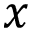<formula> <loc_0><loc_0><loc_500><loc_500>x</formula> 